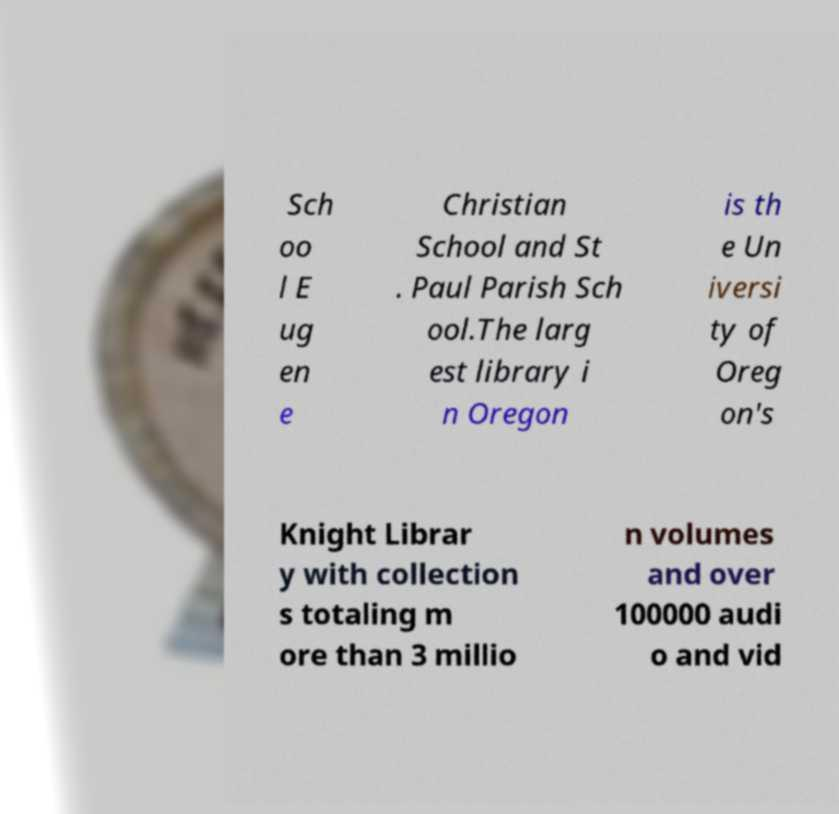For documentation purposes, I need the text within this image transcribed. Could you provide that? Sch oo l E ug en e Christian School and St . Paul Parish Sch ool.The larg est library i n Oregon is th e Un iversi ty of Oreg on's Knight Librar y with collection s totaling m ore than 3 millio n volumes and over 100000 audi o and vid 